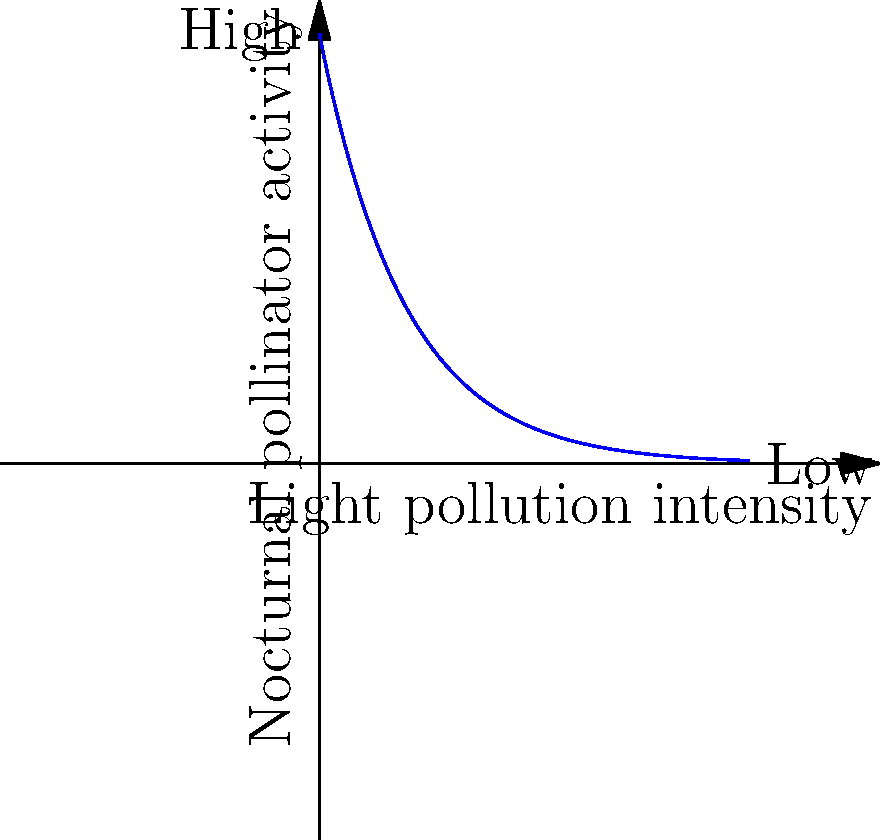Based on the graph showing the relationship between light pollution intensity and nocturnal pollinator activity, how might increasing light pollution in a national park affect native plant reproduction? To answer this question, let's analyze the graph and its implications step-by-step:

1. The graph shows an inverse relationship between light pollution intensity and nocturnal pollinator activity.

2. As light pollution intensity increases (moving right on the x-axis), nocturnal pollinator activity decreases (moving down on the y-axis).

3. The curve is exponential, indicating a rapid decrease in pollinator activity with initial increases in light pollution, followed by a more gradual decline.

4. Nocturnal pollinators, such as moths, are essential for the reproduction of many native plant species that bloom at night.

5. Reduced pollinator activity due to light pollution would lead to:
   a) Decreased pollination rates
   b) Reduced seed production
   c) Lower genetic diversity in plant populations

6. Over time, this could result in:
   a) Declining populations of native plant species
   b) Altered plant community composition
   c) Potential local extinctions of light-sensitive species

7. The impact would be most severe for plant species that rely heavily or exclusively on nocturnal pollinators.

8. Native plant restoration projects in the national park would face increased challenges, as the reduced pollination could hinder natural regeneration and the establishment of newly planted individuals.
Answer: Increasing light pollution would likely decrease native plant reproduction due to reduced nocturnal pollinator activity. 